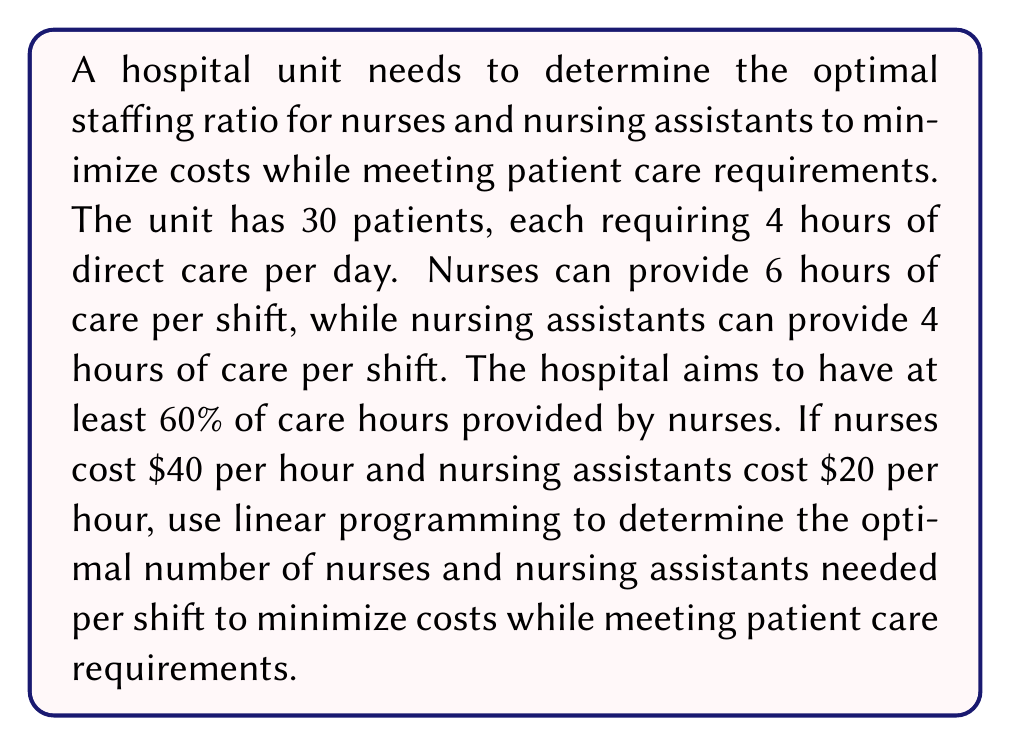Provide a solution to this math problem. Let's approach this step-by-step using linear programming:

1. Define variables:
   $x$ = number of nurses per shift
   $y$ = number of nursing assistants per shift

2. Objective function (minimize cost):
   Minimize $Z = 40x + 20y$

3. Constraints:
   a) Total care hours provided must meet or exceed patient needs:
      $6x + 4y \geq 120$ (30 patients * 4 hours each)
   
   b) At least 60% of care hours must be provided by nurses:
      $6x \geq 0.6(6x + 4y)$
      Simplifying: $4x \geq 2.4y$
   
   c) Non-negativity constraints:
      $x \geq 0, y \geq 0$

4. Solve the system of inequalities:
   From constraint (b): $x \geq 0.6y$
   Substitute this into constraint (a):
   $6(0.6y) + 4y \geq 120$
   $3.6y + 4y \geq 120$
   $7.6y \geq 120$
   $y \geq 15.79$

   Since $y$ must be an integer, $y = 16$

   Substituting back: $x \geq 0.6(16) = 9.6$
   Since $x$ must be an integer, $x = 10$

5. Verify the solution meets all constraints:
   $6(10) + 4(16) = 124 \geq 120$
   $6(10) = 60 \geq 0.6(124) = 74.4$

6. Calculate the minimum cost:
   $Z = 40(10) + 20(16) = 400 + 320 = 720$

Therefore, the optimal staffing ratio is 10 nurses and 16 nursing assistants per shift.
Answer: 10 nurses and 16 nursing assistants per shift 